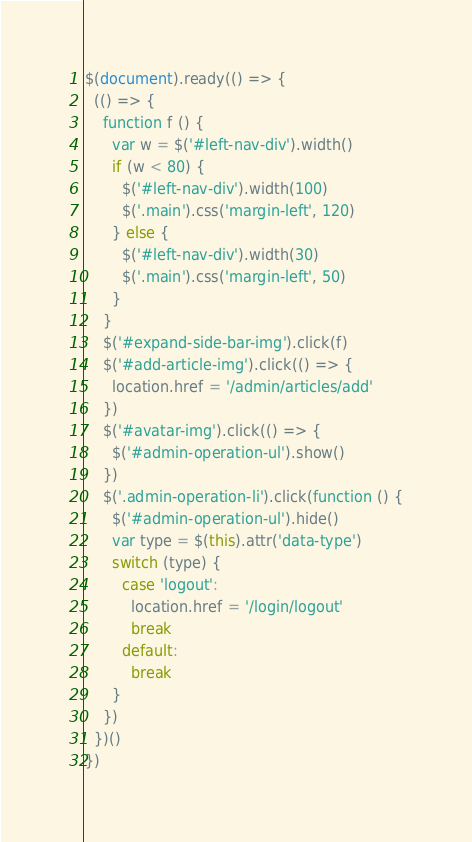<code> <loc_0><loc_0><loc_500><loc_500><_JavaScript_>$(document).ready(() => {
  (() => {
    function f () {
      var w = $('#left-nav-div').width()
      if (w < 80) {
        $('#left-nav-div').width(100)
        $('.main').css('margin-left', 120)
      } else {
        $('#left-nav-div').width(30)
        $('.main').css('margin-left', 50)
      }
    }
    $('#expand-side-bar-img').click(f)
    $('#add-article-img').click(() => {
      location.href = '/admin/articles/add'
    })
    $('#avatar-img').click(() => {
      $('#admin-operation-ul').show()
    })
    $('.admin-operation-li').click(function () {
      $('#admin-operation-ul').hide()
      var type = $(this).attr('data-type')
      switch (type) {
        case 'logout':
          location.href = '/login/logout'
          break
        default:
          break
      }
    })
  })()
})
</code> 